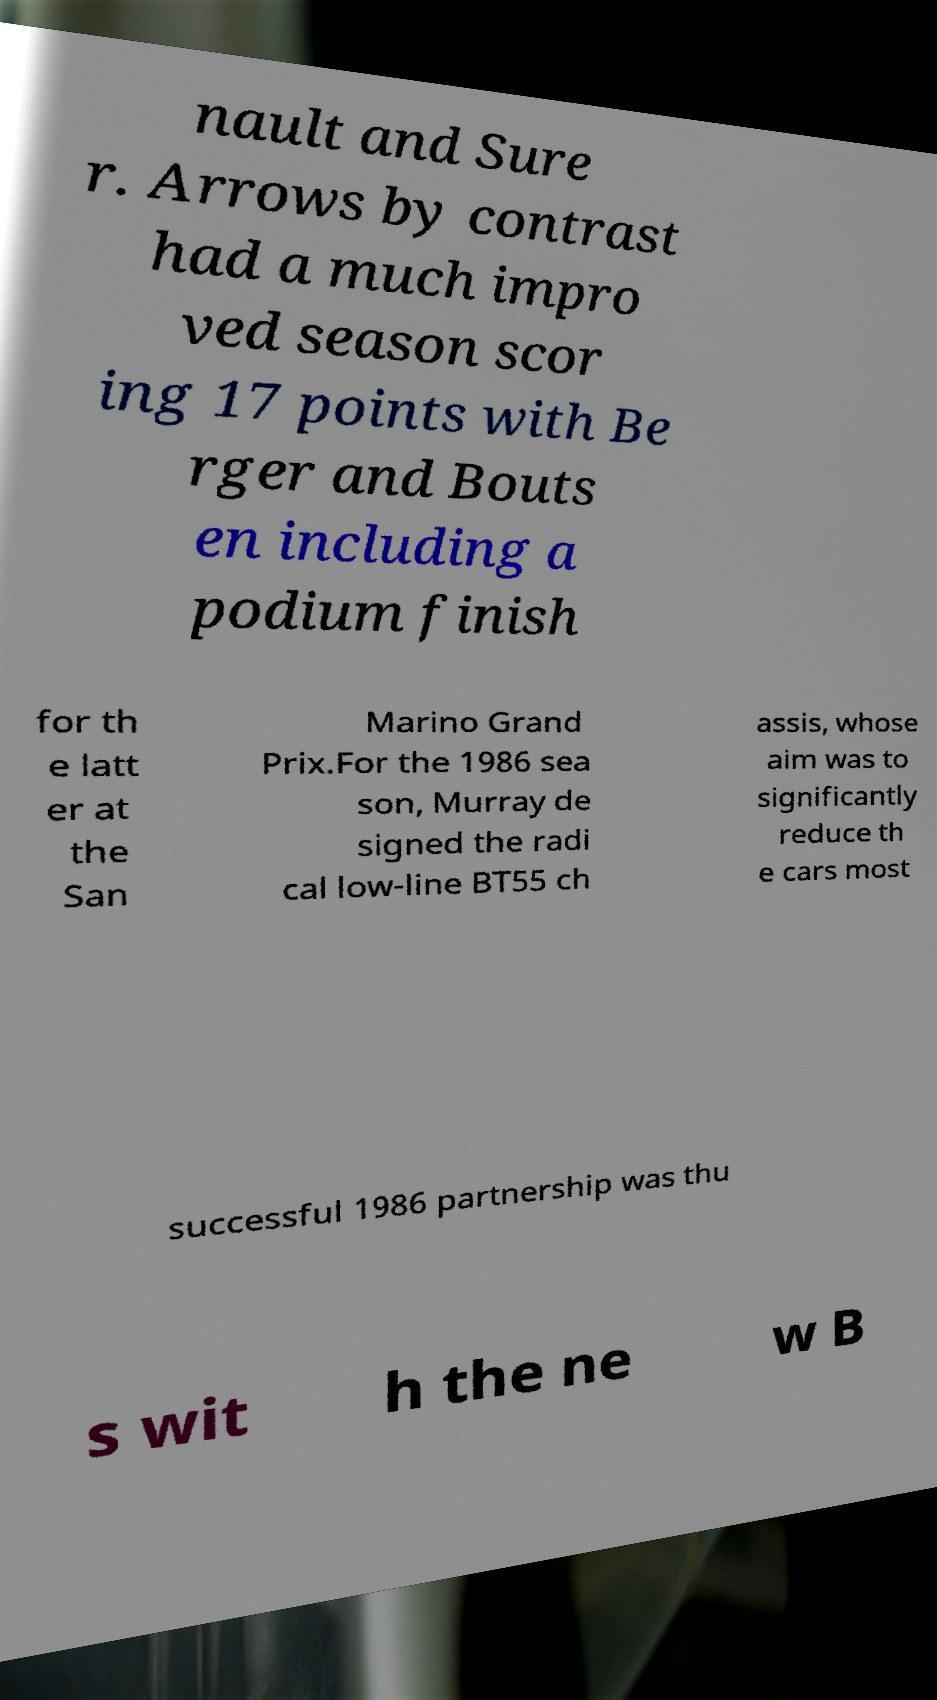For documentation purposes, I need the text within this image transcribed. Could you provide that? nault and Sure r. Arrows by contrast had a much impro ved season scor ing 17 points with Be rger and Bouts en including a podium finish for th e latt er at the San Marino Grand Prix.For the 1986 sea son, Murray de signed the radi cal low-line BT55 ch assis, whose aim was to significantly reduce th e cars most successful 1986 partnership was thu s wit h the ne w B 